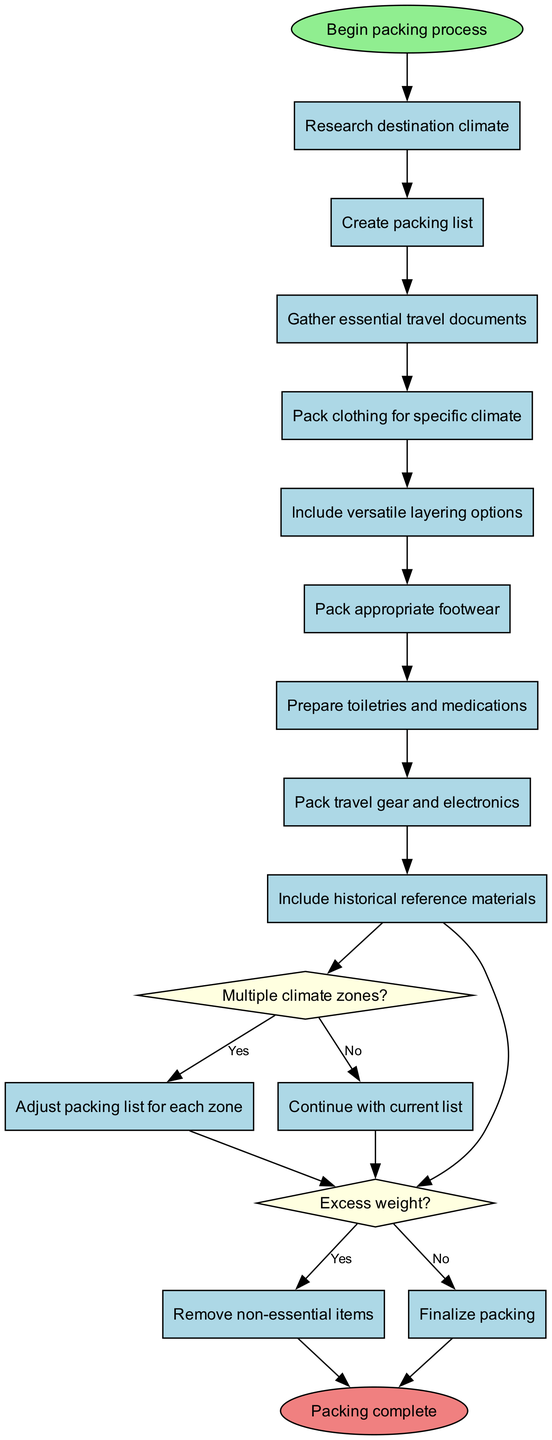What is the starting point of the packing process? The diagram begins with the "Begin packing process" node, which signifies the initiation of the packing activity.
Answer: Begin packing process How many main activities are there in the diagram? There are eight main activities listed in the diagram, as shown in the activities section.
Answer: Eight What question is asked to determine if the packing process needs adjustment for different climate zones? The decision node poses the question, "Multiple climate zones?" to evaluate whether the packing list should be adjusted based on the climate zones at the destination.
Answer: Multiple climate zones? What is the final activity in the packing process before completing? The final action taken in the diagram is "Finalize packing," which occurs just before reaching the end node "Packing complete."
Answer: Finalize packing If "Excess weight?" is answered as yes, what is the next action? Answering "Excess weight?" with a "Yes" leads to the action "Remove non-essential items," indicating that items should be discarded to meet weight requirements.
Answer: Remove non-essential items What is included besides clothing in the packing list? The packing list includes several items beyond clothing, specifically mentioned are "appropriate footwear," "toiletries and medications," "travel gear and electronics," and "historical reference materials."
Answer: Appropriate footwear, toiletries and medications, travel gear and electronics, historical reference materials At which node does the packing process change based on adjustments for climate zones? The packing process branches at the decision node "Multiple climate zones?" where it determines if the packing list requires adjustments. If yes, it leads to "Adjust packing list for each zone."
Answer: Multiple climate zones? What happens after packing clothing for specific climate? After packing clothing for specific climate, the process moves directly to the decision node that asks "Multiple climate zones?"
Answer: Multiple climate zones? 